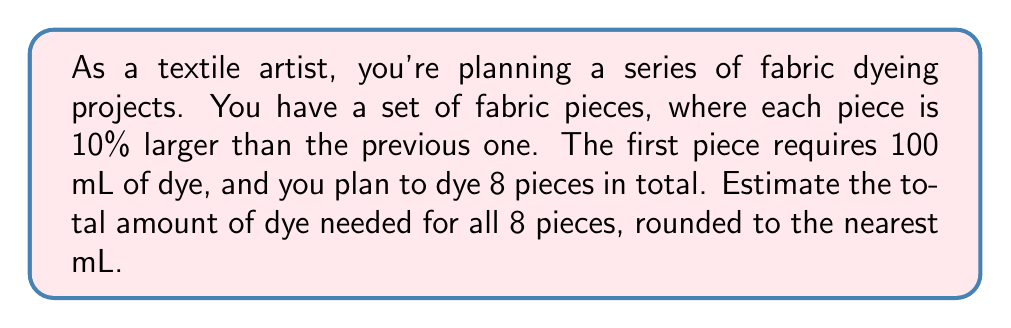Help me with this question. Let's approach this step-by-step:

1) We can model this as a geometric sequence, where each term is 1.1 times the previous term (10% larger).

2) The first term $a_1 = 100$ mL

3) The common ratio $r = 1.1$

4) We need to find the sum of 8 terms in this geometric sequence.

5) The formula for the sum of a geometric sequence is:

   $$S_n = \frac{a_1(1-r^n)}{1-r}$$

   where $S_n$ is the sum of $n$ terms, $a_1$ is the first term, and $r$ is the common ratio.

6) Plugging in our values:

   $$S_8 = \frac{100(1-1.1^8)}{1-1.1}$$

7) Let's calculate this:

   $$S_8 = \frac{100(1-2.1435887)}{-0.1}$$

   $$S_8 = \frac{100(-1.1435887)}{-0.1}$$

   $$S_8 = 1143.5887$$

8) Rounding to the nearest mL:

   $$S_8 \approx 1144\text{ mL}$$
Answer: The total amount of dye needed for all 8 pieces is approximately 1144 mL. 